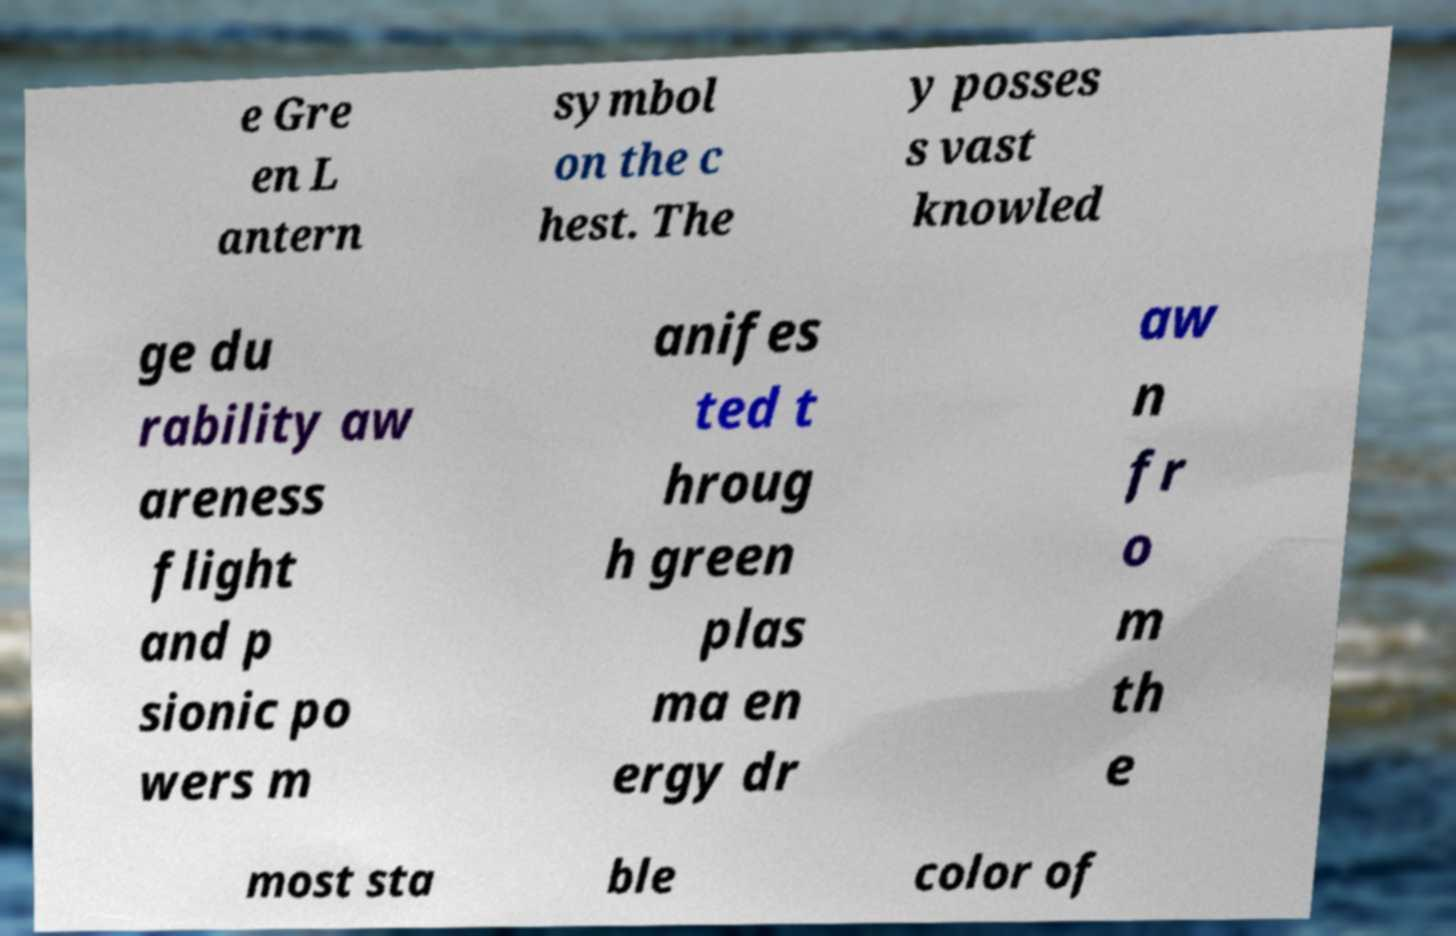Can you read and provide the text displayed in the image?This photo seems to have some interesting text. Can you extract and type it out for me? e Gre en L antern symbol on the c hest. The y posses s vast knowled ge du rability aw areness flight and p sionic po wers m anifes ted t hroug h green plas ma en ergy dr aw n fr o m th e most sta ble color of 